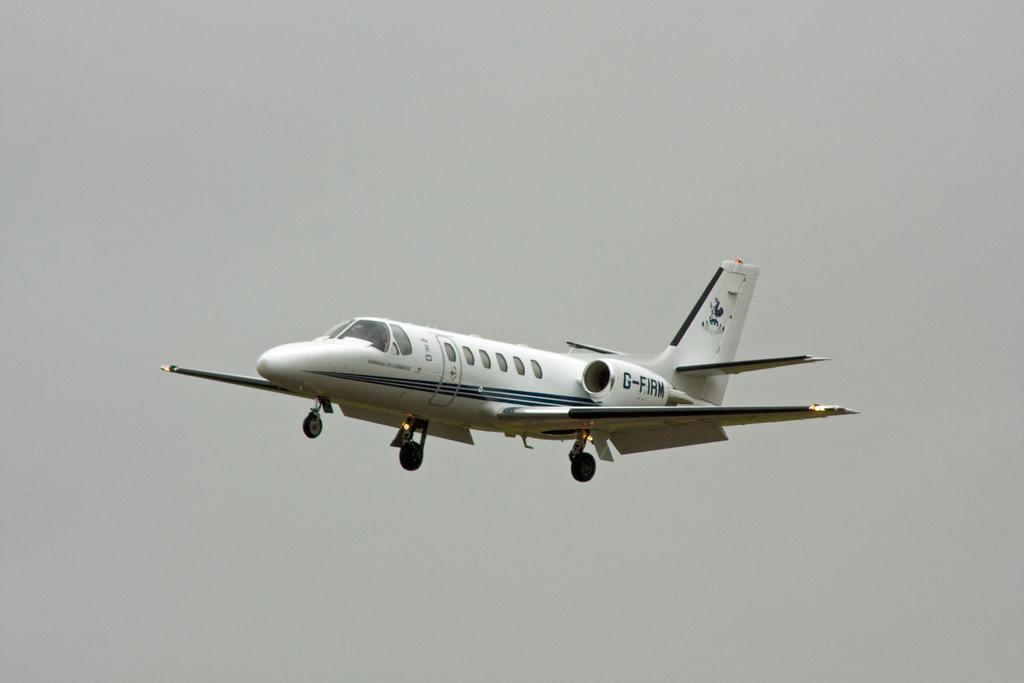Please provide a concise description of this image. In this image, we can see an airplane in the sky. 